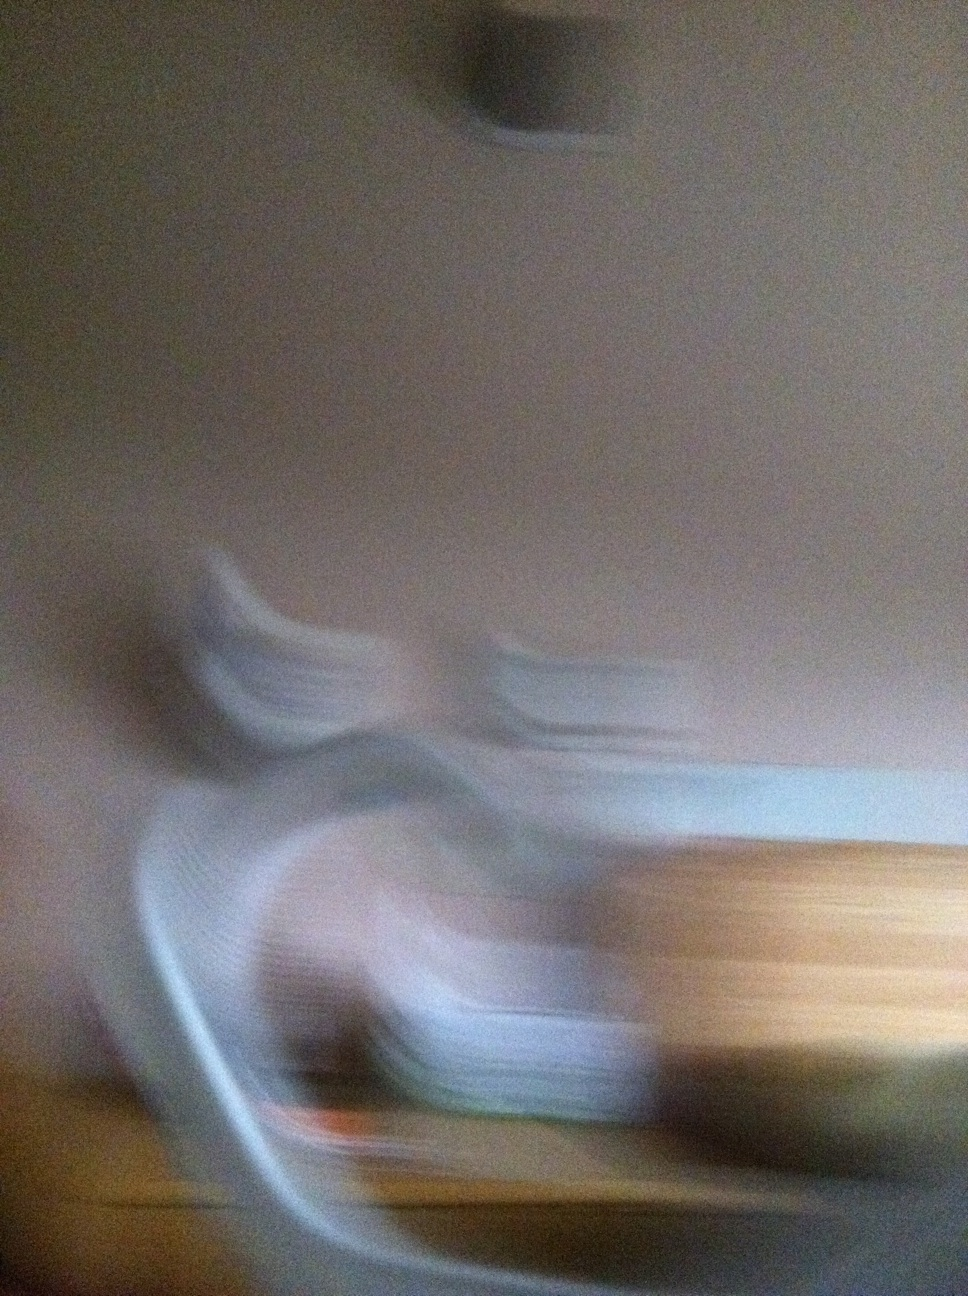what is this The image appears to be blurred and indistinct, making it difficult to determine any specific objects or scenes. It seems to capture motion, possibly caused by a moving camera. 